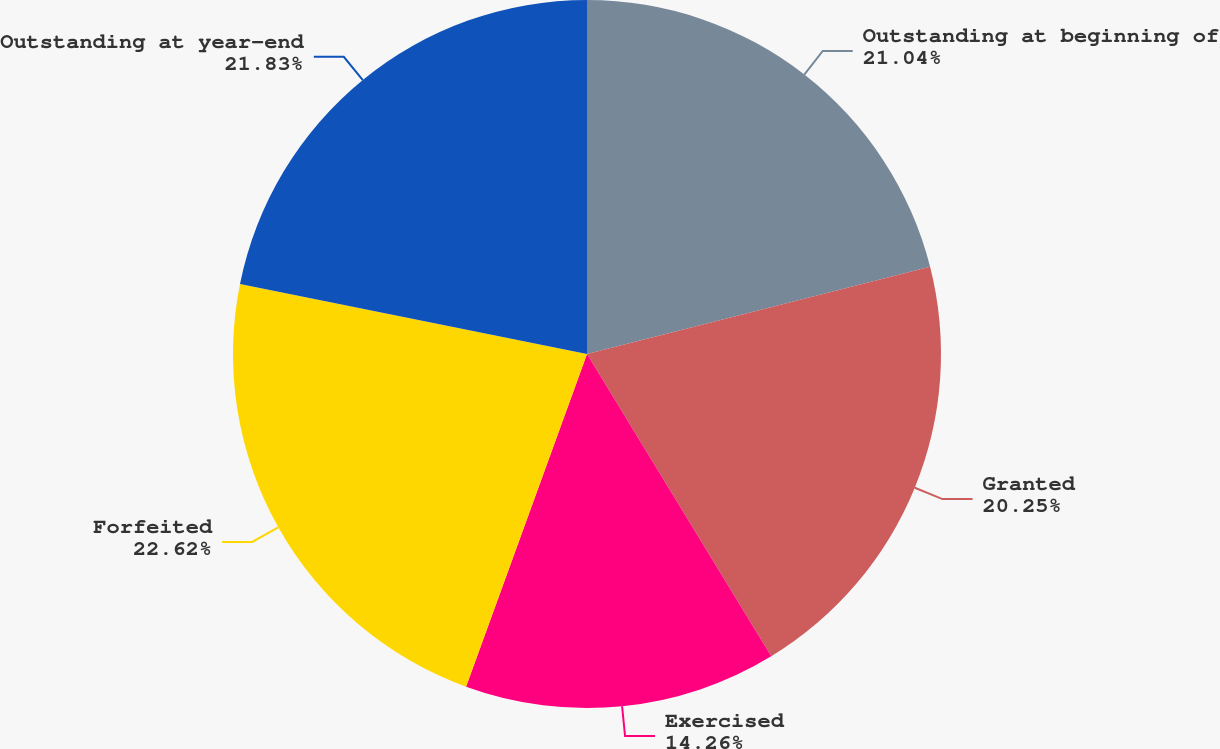Convert chart to OTSL. <chart><loc_0><loc_0><loc_500><loc_500><pie_chart><fcel>Outstanding at beginning of<fcel>Granted<fcel>Exercised<fcel>Forfeited<fcel>Outstanding at year-end<nl><fcel>21.04%<fcel>20.25%<fcel>14.26%<fcel>22.62%<fcel>21.83%<nl></chart> 